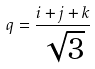<formula> <loc_0><loc_0><loc_500><loc_500>q = \frac { i + j + k } { \sqrt { 3 } }</formula> 